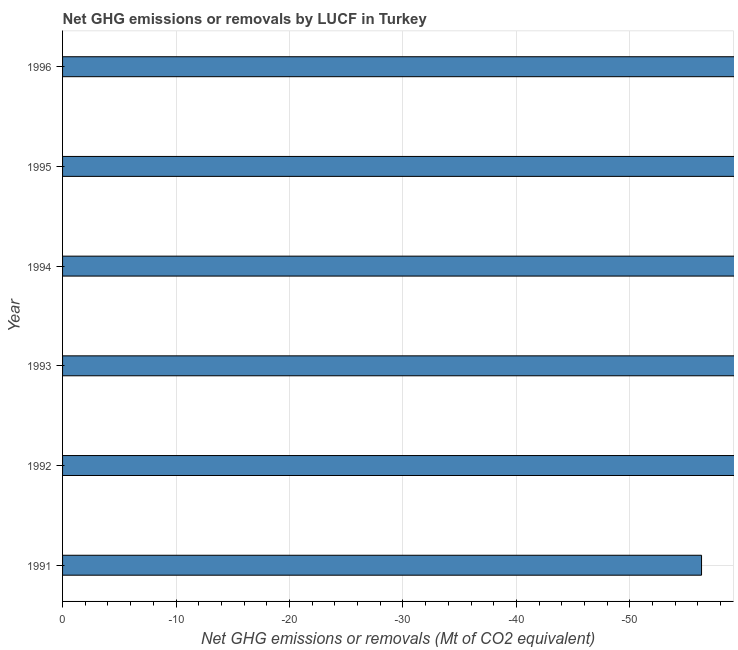What is the title of the graph?
Your answer should be compact. Net GHG emissions or removals by LUCF in Turkey. What is the label or title of the X-axis?
Offer a terse response. Net GHG emissions or removals (Mt of CO2 equivalent). What is the average ghg net emissions or removals per year?
Your answer should be very brief. 0. What is the median ghg net emissions or removals?
Provide a short and direct response. 0. In how many years, is the ghg net emissions or removals greater than -38 Mt?
Give a very brief answer. 0. In how many years, is the ghg net emissions or removals greater than the average ghg net emissions or removals taken over all years?
Offer a very short reply. 0. How many years are there in the graph?
Your response must be concise. 6. What is the difference between two consecutive major ticks on the X-axis?
Ensure brevity in your answer.  10. What is the Net GHG emissions or removals (Mt of CO2 equivalent) of 1991?
Keep it short and to the point. 0. What is the Net GHG emissions or removals (Mt of CO2 equivalent) of 1994?
Give a very brief answer. 0. What is the Net GHG emissions or removals (Mt of CO2 equivalent) of 1996?
Provide a succinct answer. 0. 